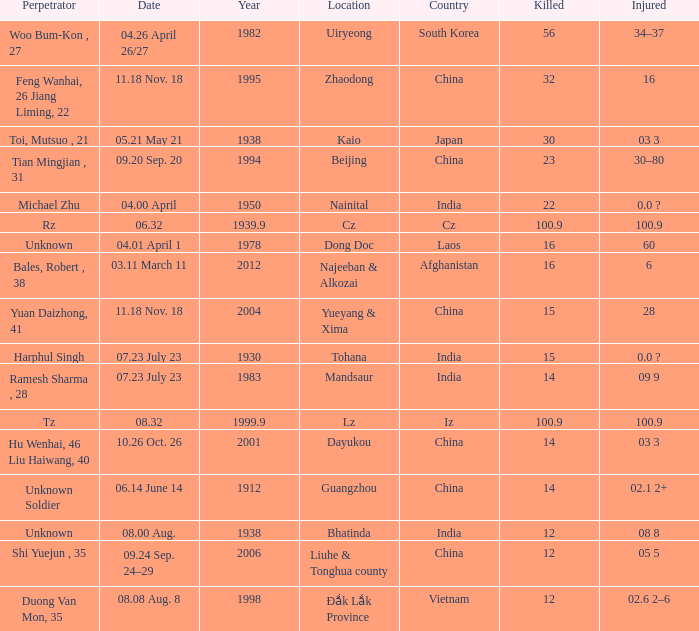9, and when "year" exceeds 193 Iz. 